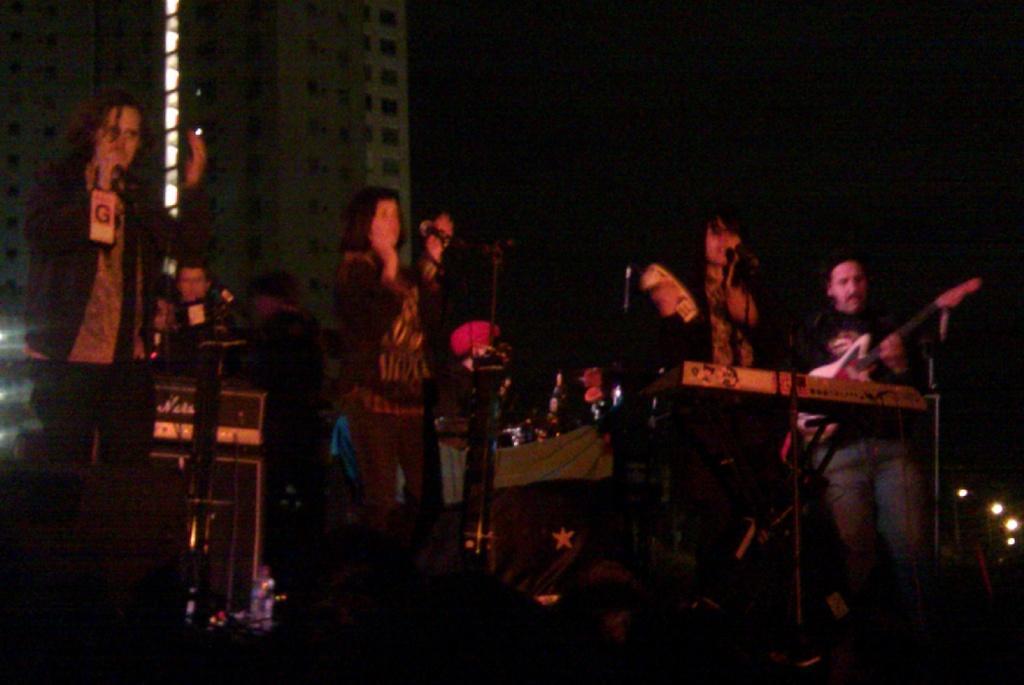Describe this image in one or two sentences. In this picture we can see a group of people, here we can see musical instruments, buildings and in the background we can see it is dark. 